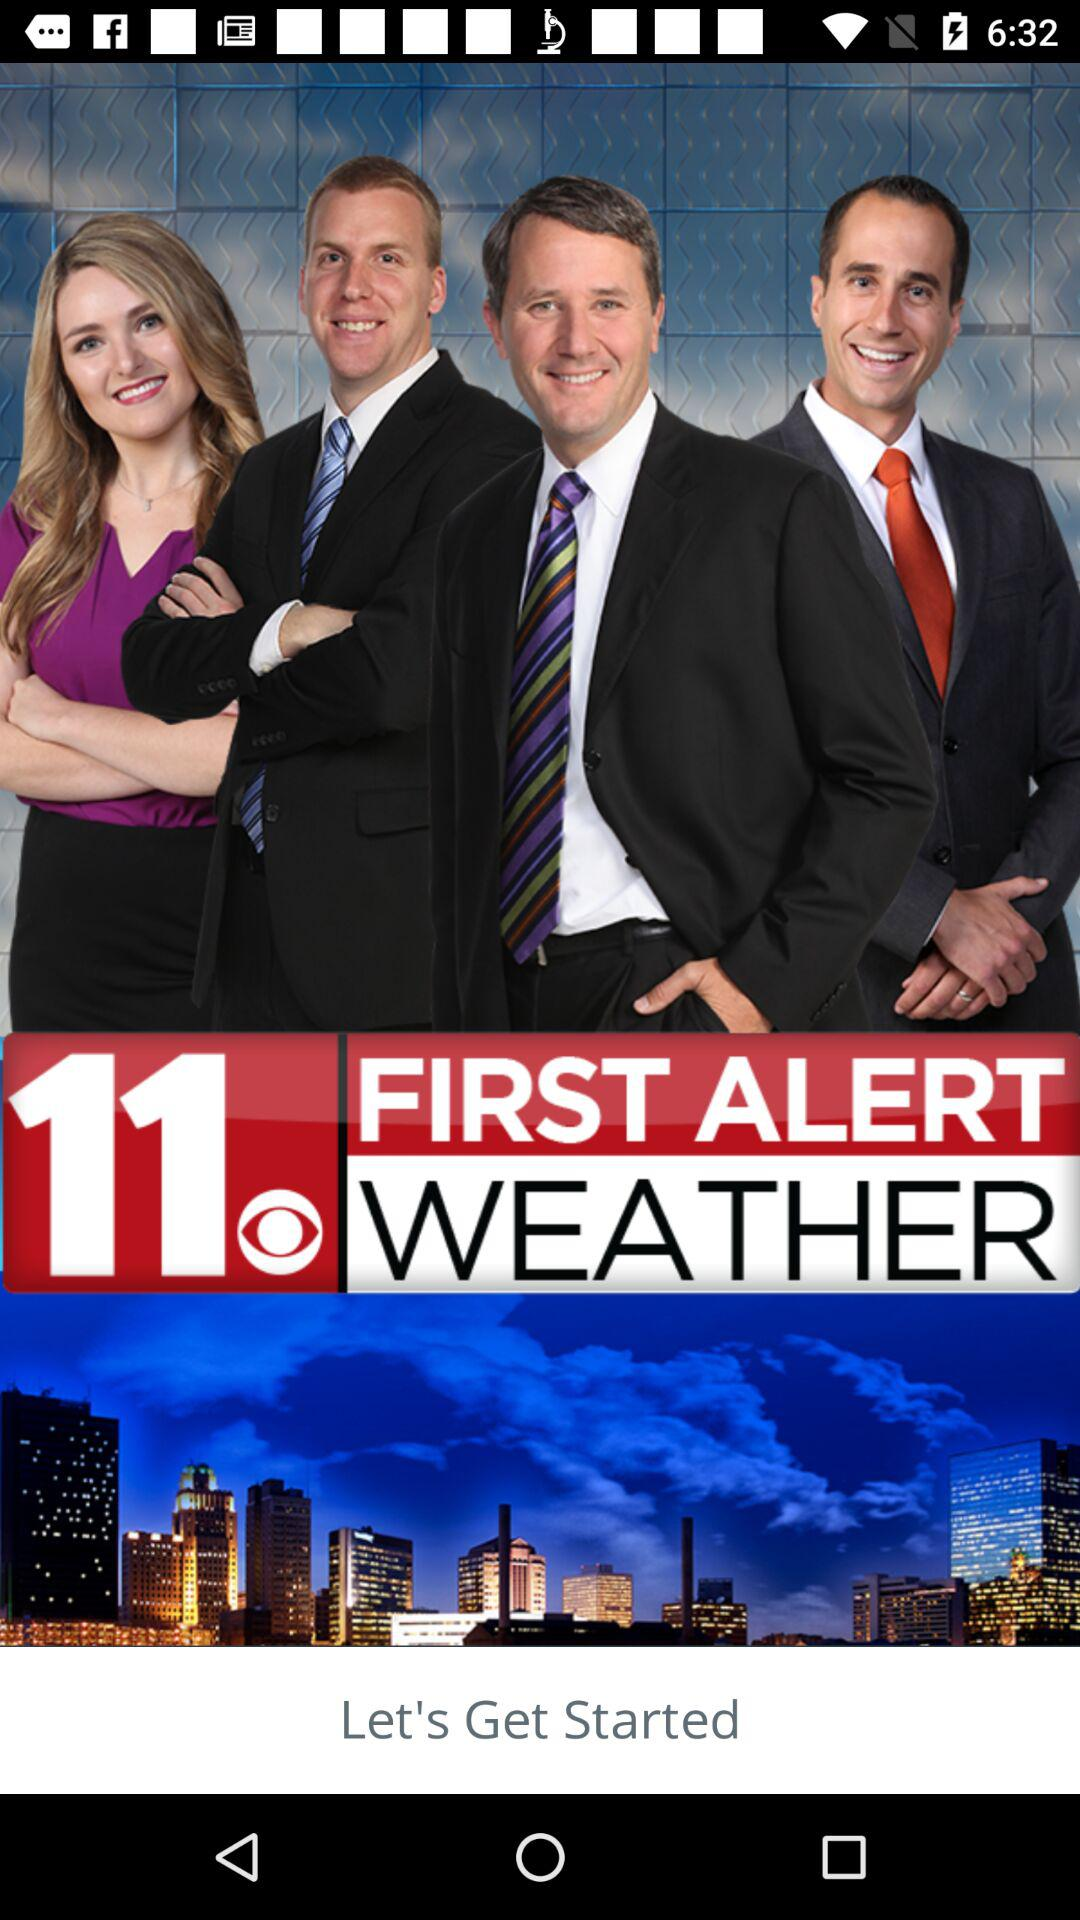What is the name of the application? The name of the application is "FIRST ALERT WEATHER". 